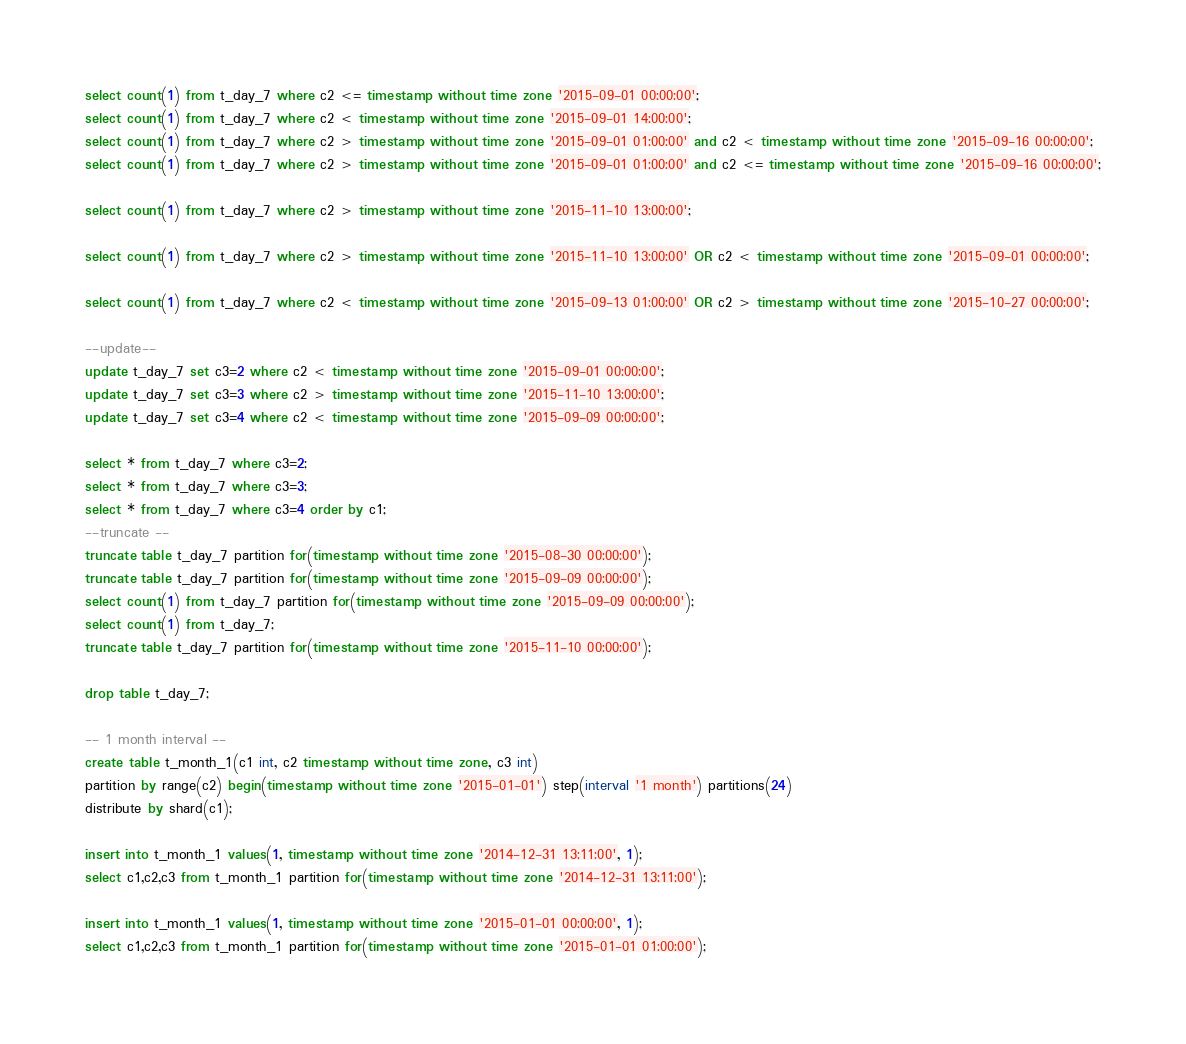Convert code to text. <code><loc_0><loc_0><loc_500><loc_500><_SQL_>select count(1) from t_day_7 where c2 <= timestamp without time zone '2015-09-01 00:00:00';
select count(1) from t_day_7 where c2 < timestamp without time zone '2015-09-01 14:00:00';
select count(1) from t_day_7 where c2 > timestamp without time zone '2015-09-01 01:00:00' and c2 < timestamp without time zone '2015-09-16 00:00:00';
select count(1) from t_day_7 where c2 > timestamp without time zone '2015-09-01 01:00:00' and c2 <= timestamp without time zone '2015-09-16 00:00:00';
                           
select count(1) from t_day_7 where c2 > timestamp without time zone '2015-11-10 13:00:00';
                           
select count(1) from t_day_7 where c2 > timestamp without time zone '2015-11-10 13:00:00' OR c2 < timestamp without time zone '2015-09-01 00:00:00';
                           
select count(1) from t_day_7 where c2 < timestamp without time zone '2015-09-13 01:00:00' OR c2 > timestamp without time zone '2015-10-27 00:00:00';

--update--
update t_day_7 set c3=2 where c2 < timestamp without time zone '2015-09-01 00:00:00';
update t_day_7 set c3=3 where c2 > timestamp without time zone '2015-11-10 13:00:00';
update t_day_7 set c3=4 where c2 < timestamp without time zone '2015-09-09 00:00:00';

select * from t_day_7 where c3=2;
select * from t_day_7 where c3=3;
select * from t_day_7 where c3=4 order by c1;
--truncate --
truncate table t_day_7 partition for(timestamp without time zone '2015-08-30 00:00:00');
truncate table t_day_7 partition for(timestamp without time zone '2015-09-09 00:00:00');
select count(1) from t_day_7 partition for(timestamp without time zone '2015-09-09 00:00:00');
select count(1) from t_day_7;
truncate table t_day_7 partition for(timestamp without time zone '2015-11-10 00:00:00');

drop table t_day_7;

-- 1 month interval -- 
create table t_month_1(c1 int, c2 timestamp without time zone, c3 int)
partition by range(c2) begin(timestamp without time zone '2015-01-01') step(interval '1 month') partitions(24)
distribute by shard(c1);

insert into t_month_1 values(1, timestamp without time zone '2014-12-31 13:11:00', 1);
select c1,c2,c3 from t_month_1 partition for(timestamp without time zone '2014-12-31 13:11:00');

insert into t_month_1 values(1, timestamp without time zone '2015-01-01 00:00:00', 1);
select c1,c2,c3 from t_month_1 partition for(timestamp without time zone '2015-01-01 01:00:00');
</code> 